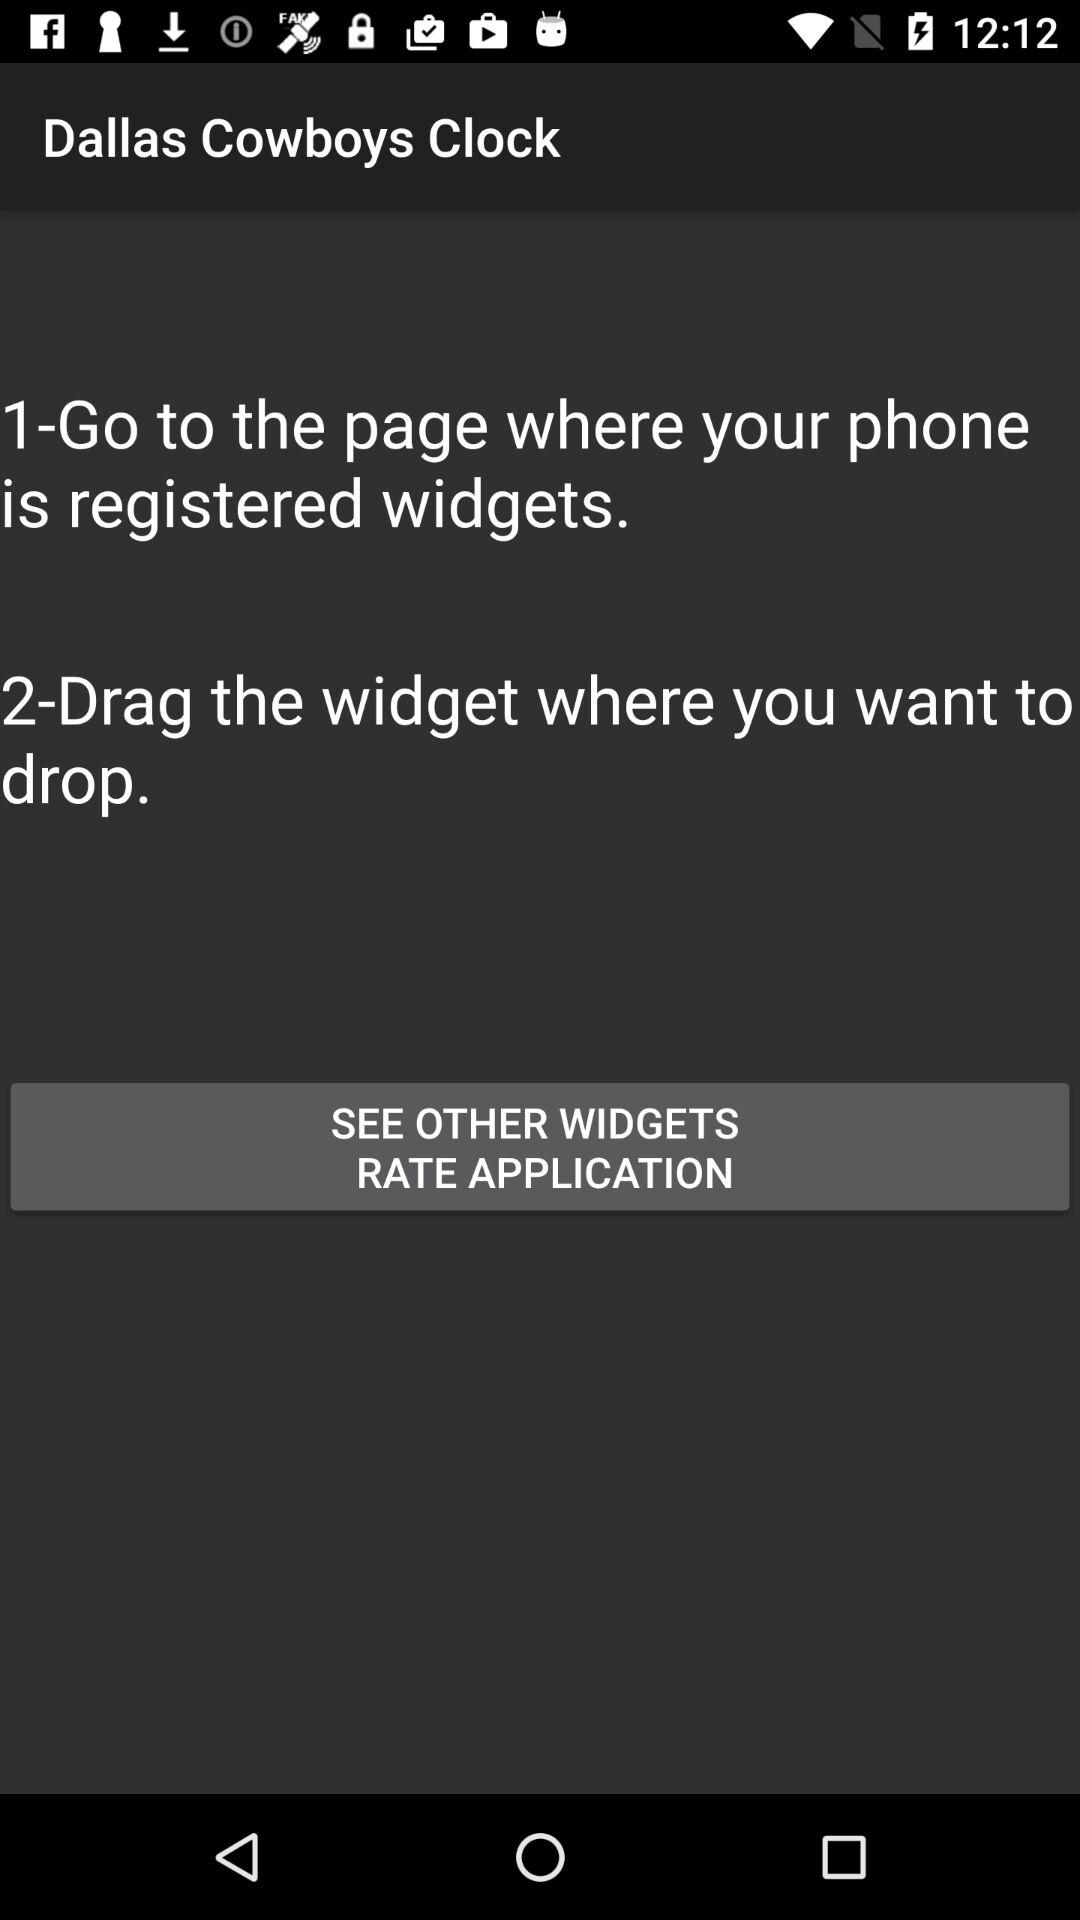How many steps are there in the guide?
Answer the question using a single word or phrase. 2 